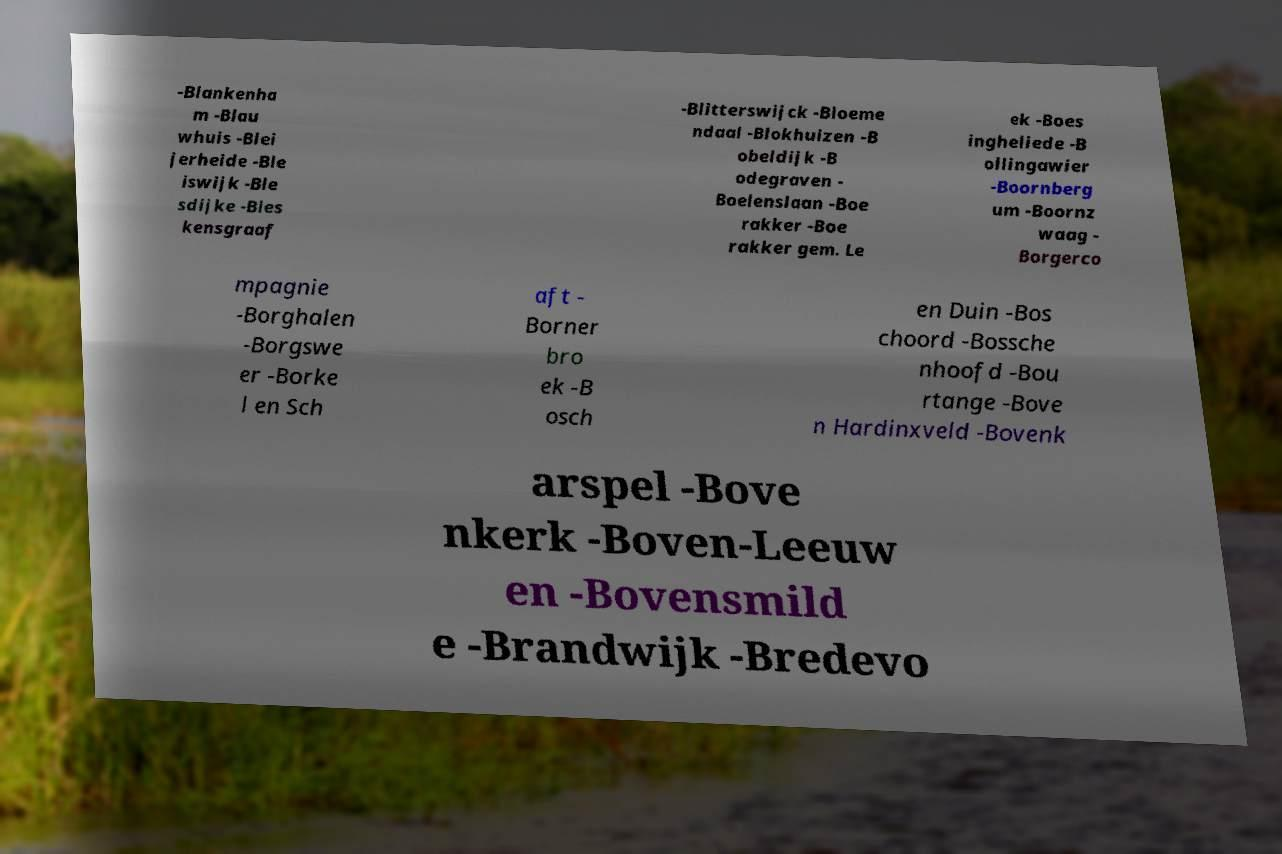I need the written content from this picture converted into text. Can you do that? -Blankenha m -Blau whuis -Blei jerheide -Ble iswijk -Ble sdijke -Bles kensgraaf -Blitterswijck -Bloeme ndaal -Blokhuizen -B obeldijk -B odegraven - Boelenslaan -Boe rakker -Boe rakker gem. Le ek -Boes ingheliede -B ollingawier -Boornberg um -Boornz waag - Borgerco mpagnie -Borghalen -Borgswe er -Borke l en Sch aft - Borner bro ek -B osch en Duin -Bos choord -Bossche nhoofd -Bou rtange -Bove n Hardinxveld -Bovenk arspel -Bove nkerk -Boven-Leeuw en -Bovensmild e -Brandwijk -Bredevo 